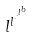<formula> <loc_0><loc_0><loc_500><loc_500>l ^ { l ^ { \cdot ^ { \cdot ^ { l ^ { b } } } } }</formula> 